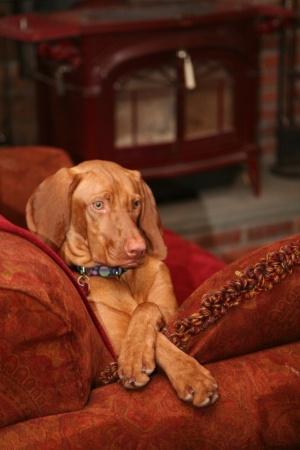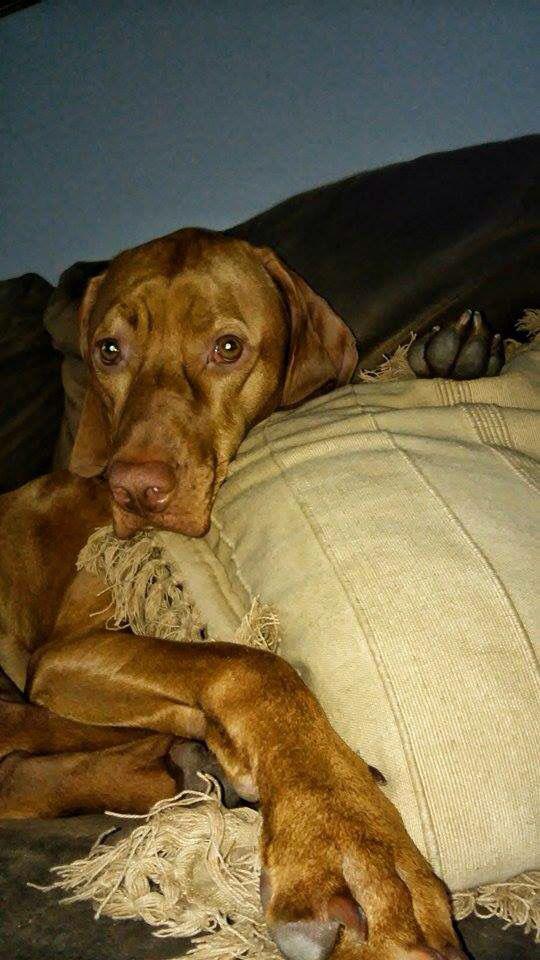The first image is the image on the left, the second image is the image on the right. Examine the images to the left and right. Is the description "At least one dog is laying on a pillow." accurate? Answer yes or no. Yes. The first image is the image on the left, the second image is the image on the right. Analyze the images presented: Is the assertion "The left image shows a fog in a reclining pose, and the dark toes on the underside of a dog's front paw are visible in the image on the right." valid? Answer yes or no. Yes. 